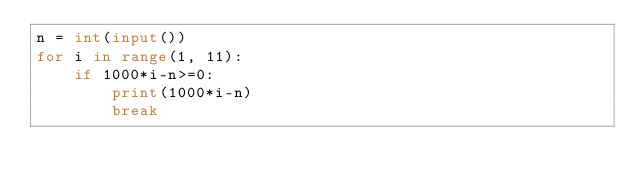<code> <loc_0><loc_0><loc_500><loc_500><_Python_>n = int(input())
for i in range(1, 11):
    if 1000*i-n>=0:
        print(1000*i-n)
        break</code> 